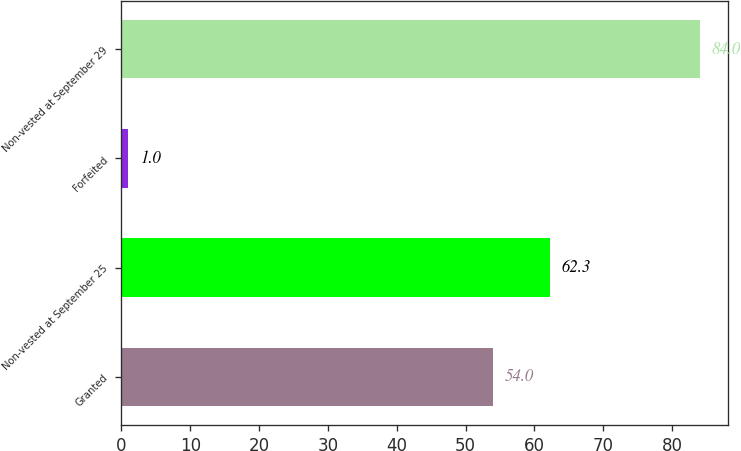Convert chart. <chart><loc_0><loc_0><loc_500><loc_500><bar_chart><fcel>Granted<fcel>Non-vested at September 25<fcel>Forfeited<fcel>Non-vested at September 29<nl><fcel>54<fcel>62.3<fcel>1<fcel>84<nl></chart> 